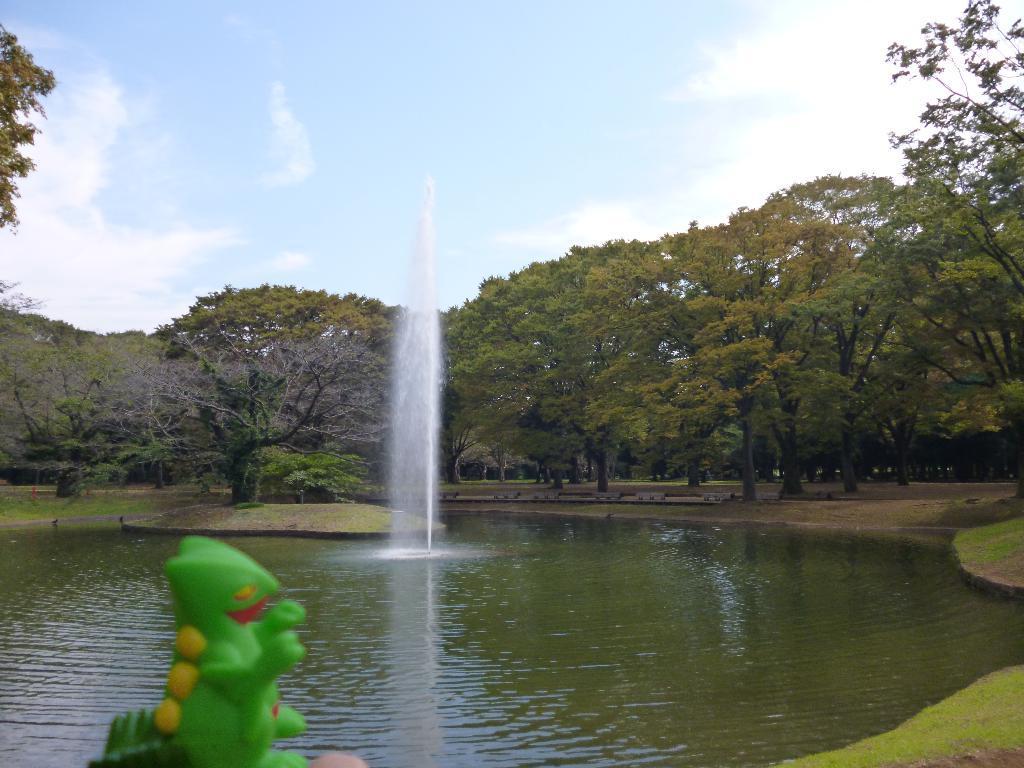Please provide a concise description of this image. In the picture we can see a canal and water with a fountain in it and around the canal we can see a grass surface with trees and in the background we can see the sky and clouds. 